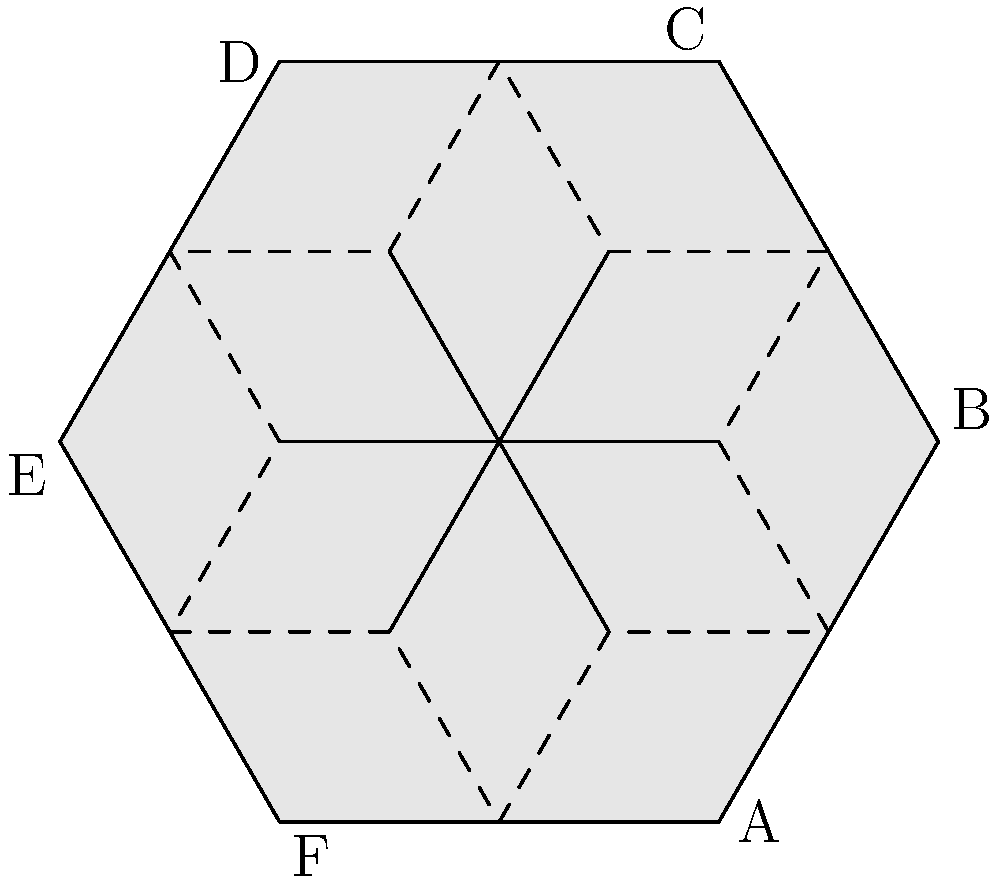In the honeycomb structure of a beehive, each cell is shaped like a regular hexagon. Consider the central hexagon ABCDEF in the diagram. If the side length of each hexagon is $s$, what is the ratio of the area of the central hexagon to the total area of the six surrounding partial hexagons? Let's approach this step-by-step:

1) Area of a regular hexagon with side length $s$:
   $A_{hexagon} = \frac{3\sqrt{3}}{2}s^2$

2) The surrounding hexagons are each divided into thirds, with one-third visible in the diagram.

3) Area of one-third of a hexagon:
   $A_{partial} = \frac{1}{3} \cdot \frac{3\sqrt{3}}{2}s^2 = \frac{\sqrt{3}}{2}s^2$

4) There are six partial hexagons surrounding the central one.
   Total area of partial hexagons:
   $A_{total partial} = 6 \cdot \frac{\sqrt{3}}{2}s^2 = 3\sqrt{3}s^2$

5) Ratio of central hexagon area to total area of partial hexagons:
   $\frac{A_{hexagon}}{A_{total partial}} = \frac{\frac{3\sqrt{3}}{2}s^2}{3\sqrt{3}s^2} = \frac{1}{2}$

This 1:2 ratio demonstrates the efficiency of the hexagonal structure in maximizing space utilization, a testament to the adaptability and resourcefulness of bees in nature.
Answer: $1:2$ or $\frac{1}{2}$ 